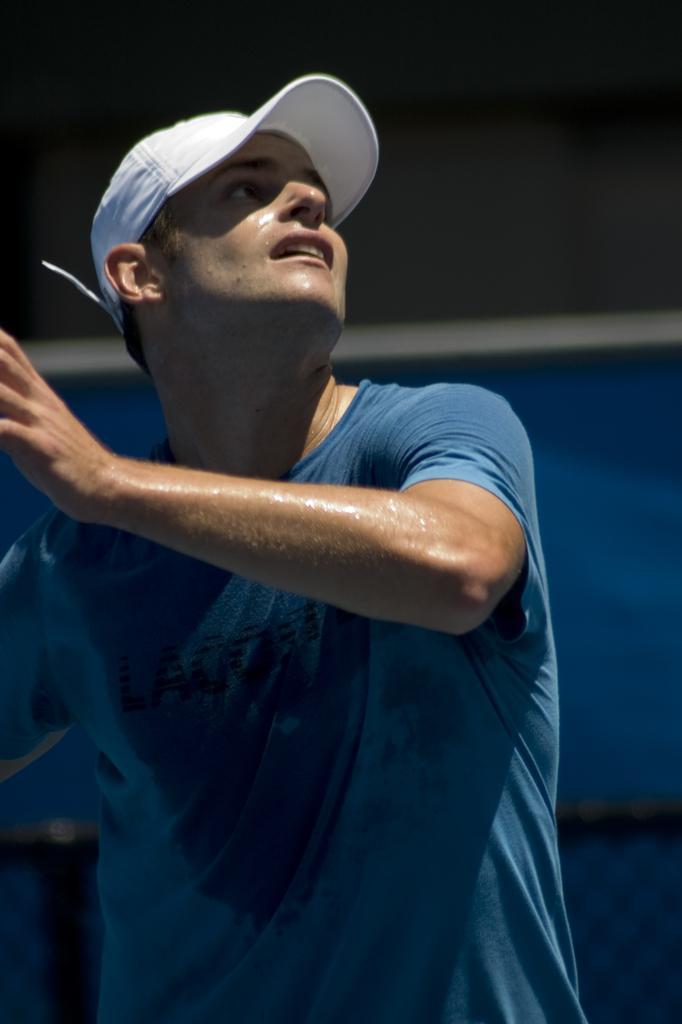Could you give a brief overview of what you see in this image? In the center of the image there is a person wearing blue color t-shirt and white color cap. 